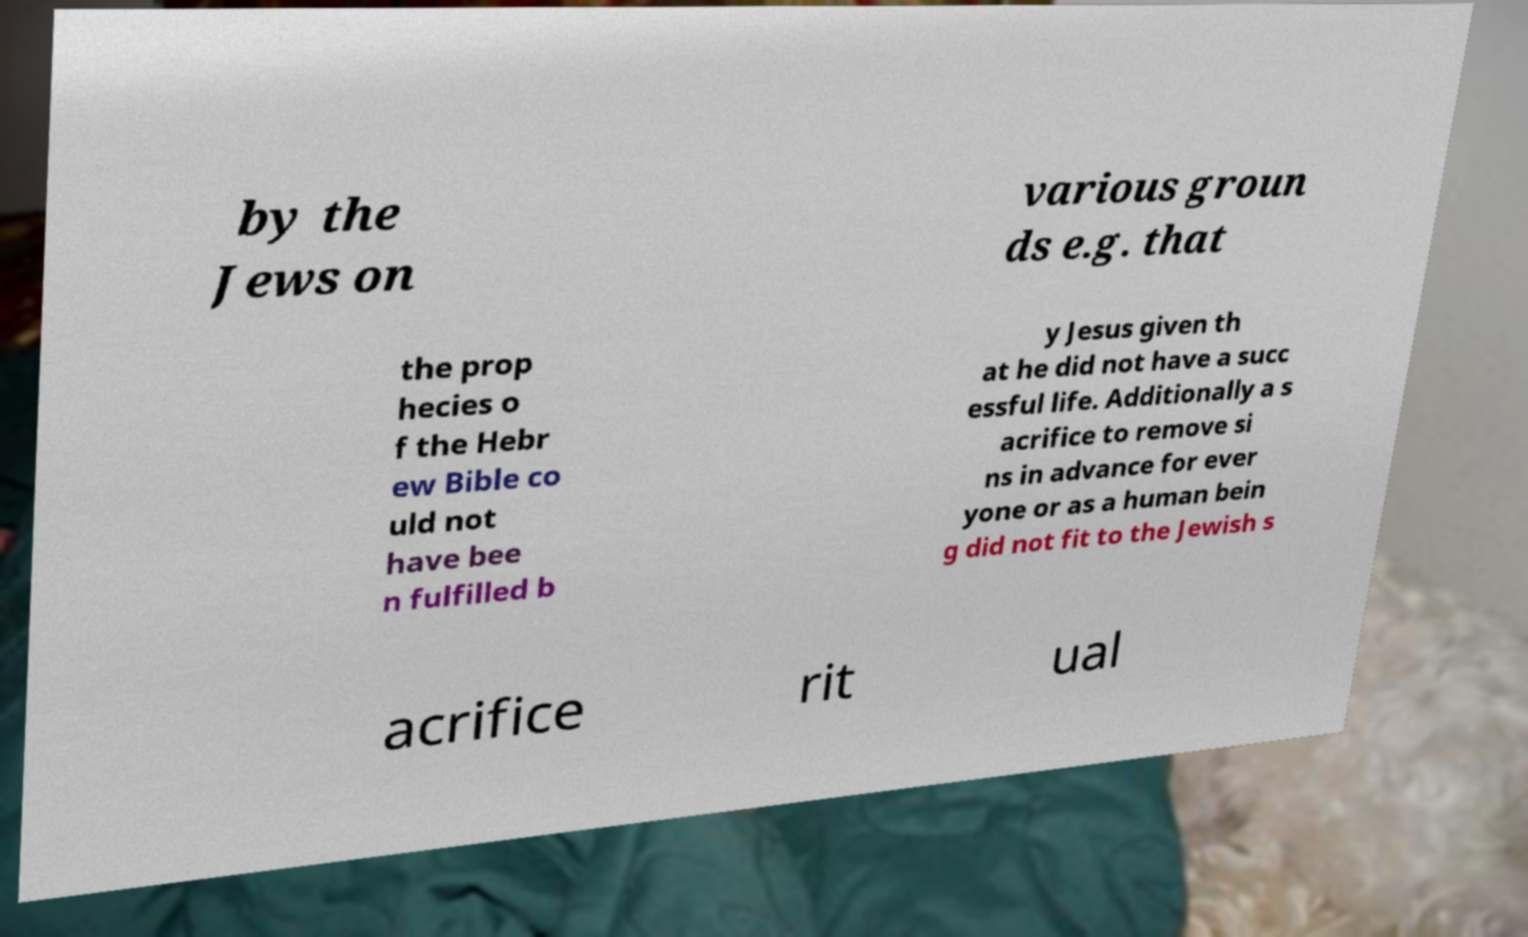Could you extract and type out the text from this image? by the Jews on various groun ds e.g. that the prop hecies o f the Hebr ew Bible co uld not have bee n fulfilled b y Jesus given th at he did not have a succ essful life. Additionally a s acrifice to remove si ns in advance for ever yone or as a human bein g did not fit to the Jewish s acrifice rit ual 